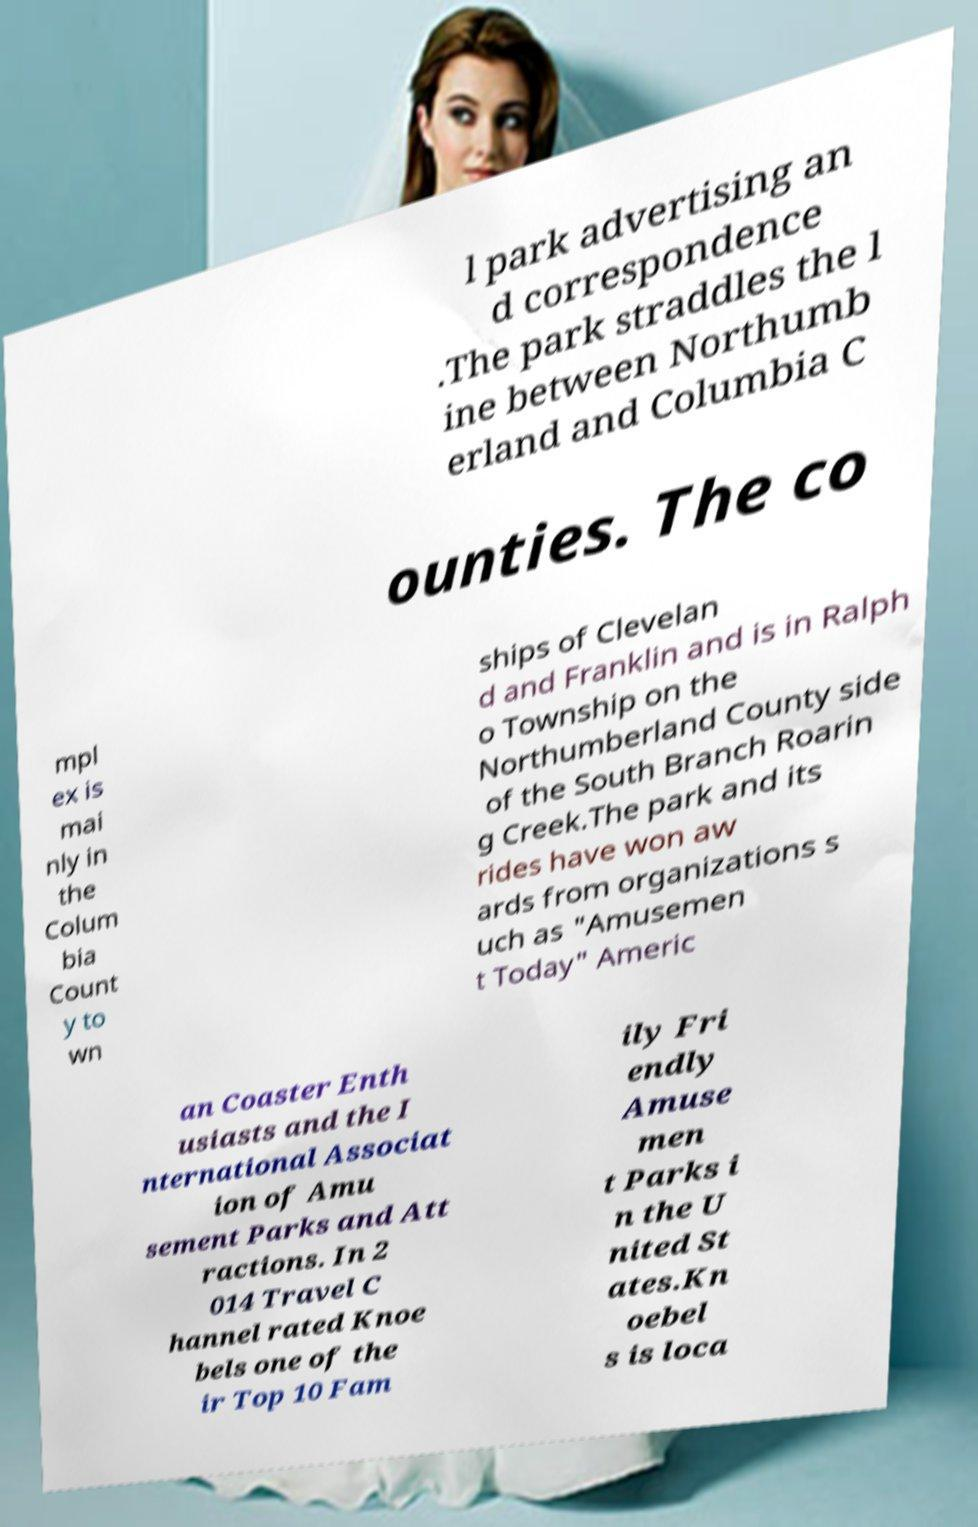Could you assist in decoding the text presented in this image and type it out clearly? l park advertising an d correspondence .The park straddles the l ine between Northumb erland and Columbia C ounties. The co mpl ex is mai nly in the Colum bia Count y to wn ships of Clevelan d and Franklin and is in Ralph o Township on the Northumberland County side of the South Branch Roarin g Creek.The park and its rides have won aw ards from organizations s uch as "Amusemen t Today" Americ an Coaster Enth usiasts and the I nternational Associat ion of Amu sement Parks and Att ractions. In 2 014 Travel C hannel rated Knoe bels one of the ir Top 10 Fam ily Fri endly Amuse men t Parks i n the U nited St ates.Kn oebel s is loca 